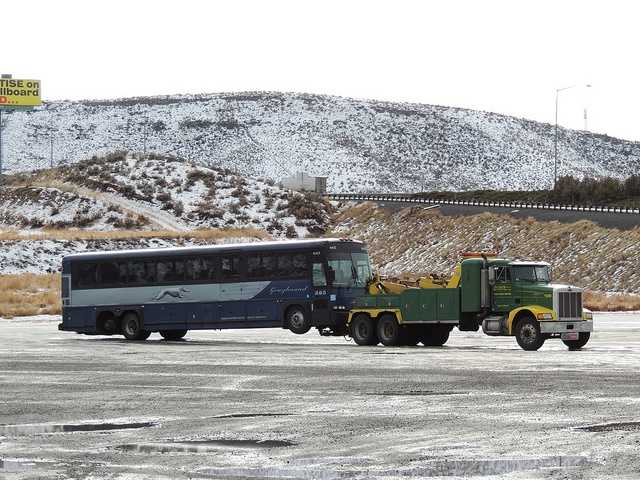Describe the objects in this image and their specific colors. I can see bus in white, black, and gray tones, truck in white, black, darkgreen, gray, and darkgray tones, and dog in white, gray, darkgray, and black tones in this image. 